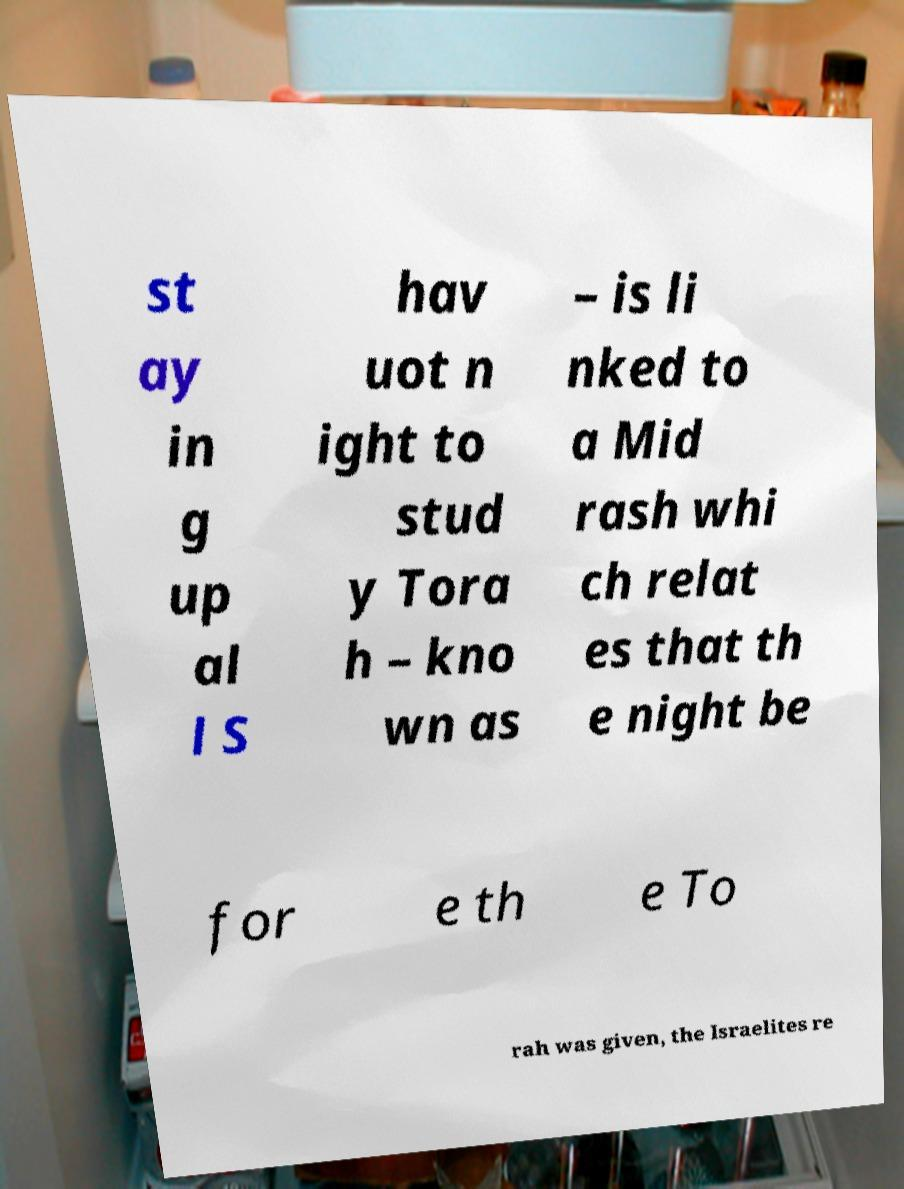Could you assist in decoding the text presented in this image and type it out clearly? st ay in g up al l S hav uot n ight to stud y Tora h – kno wn as – is li nked to a Mid rash whi ch relat es that th e night be for e th e To rah was given, the Israelites re 